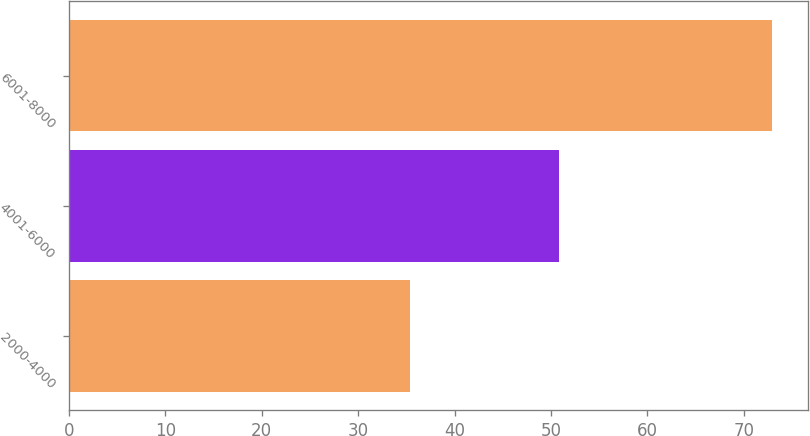Convert chart to OTSL. <chart><loc_0><loc_0><loc_500><loc_500><bar_chart><fcel>2000-4000<fcel>4001-6000<fcel>6001-8000<nl><fcel>35.4<fcel>50.8<fcel>72.95<nl></chart> 